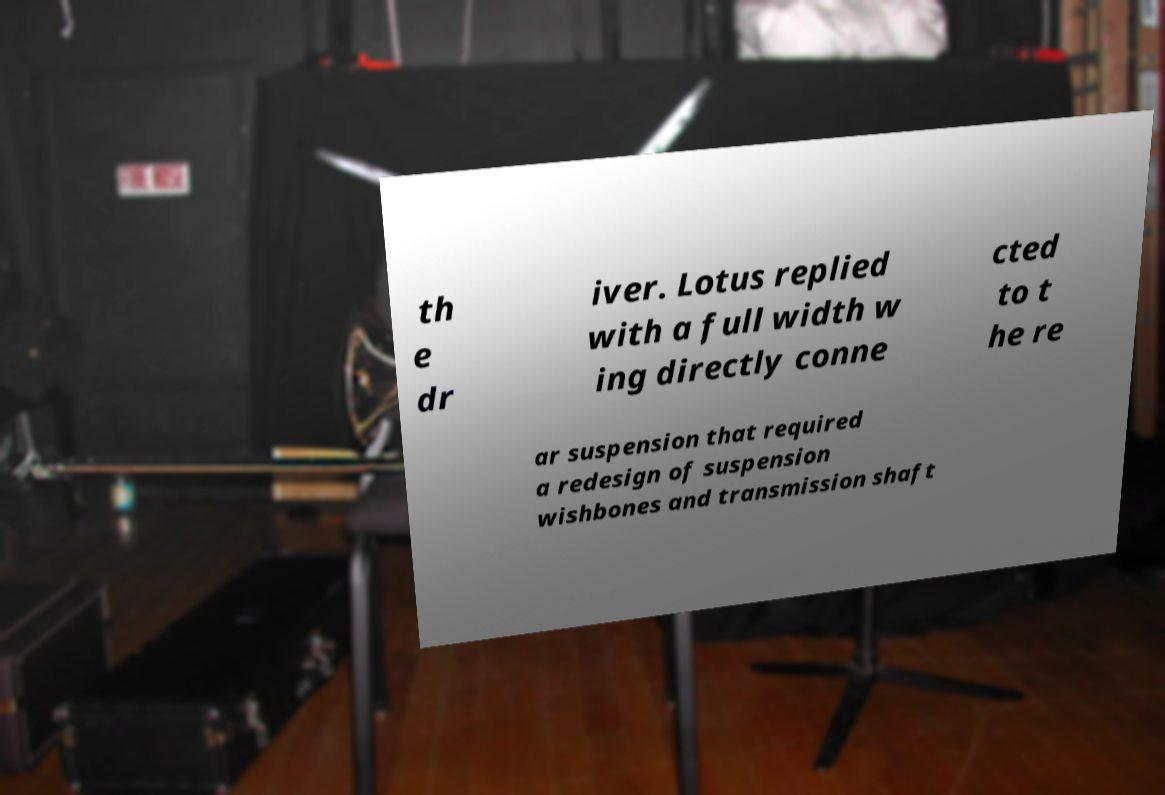Please identify and transcribe the text found in this image. th e dr iver. Lotus replied with a full width w ing directly conne cted to t he re ar suspension that required a redesign of suspension wishbones and transmission shaft 